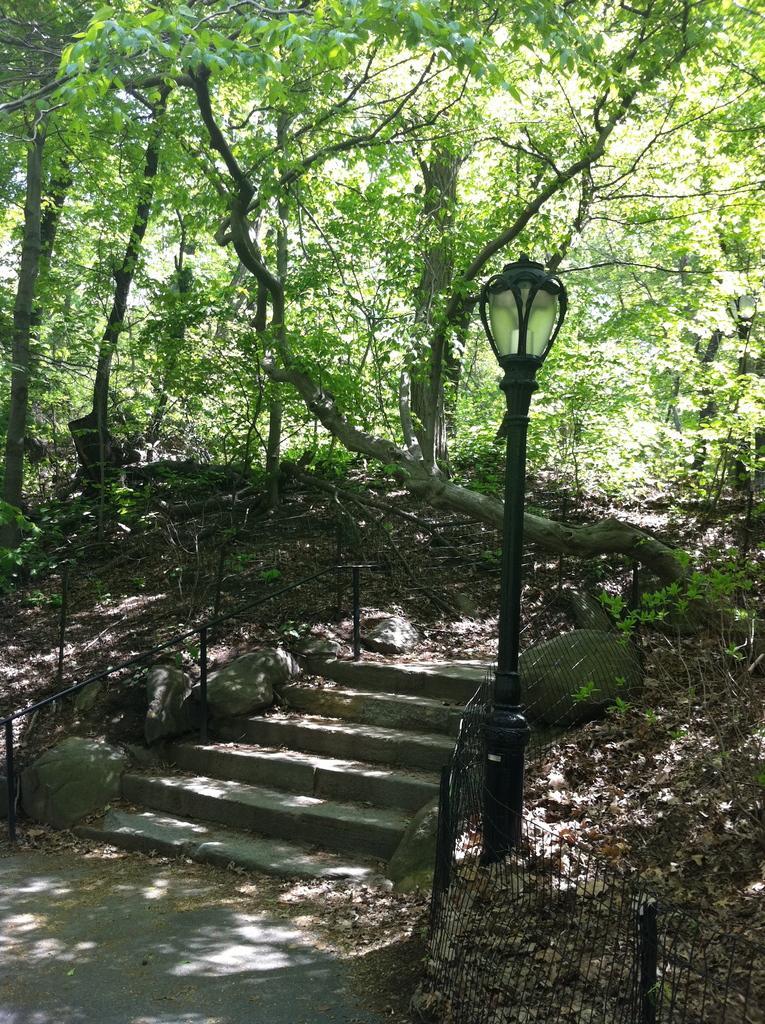How would you summarize this image in a sentence or two? In this image we can see stairs, fencing and a pole with a light. Behind the stairs we can see a group of trees. 